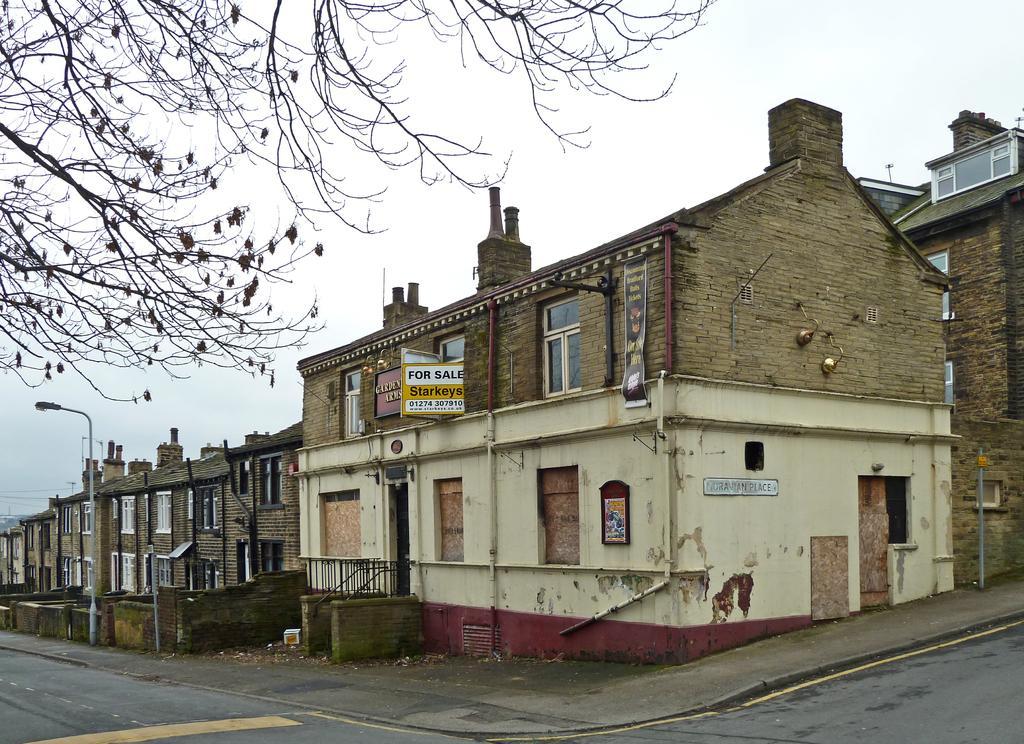How would you summarize this image in a sentence or two? In this image there are buildings, in front of the buildings there is a street light, trees, road and in the background there is the sky. 